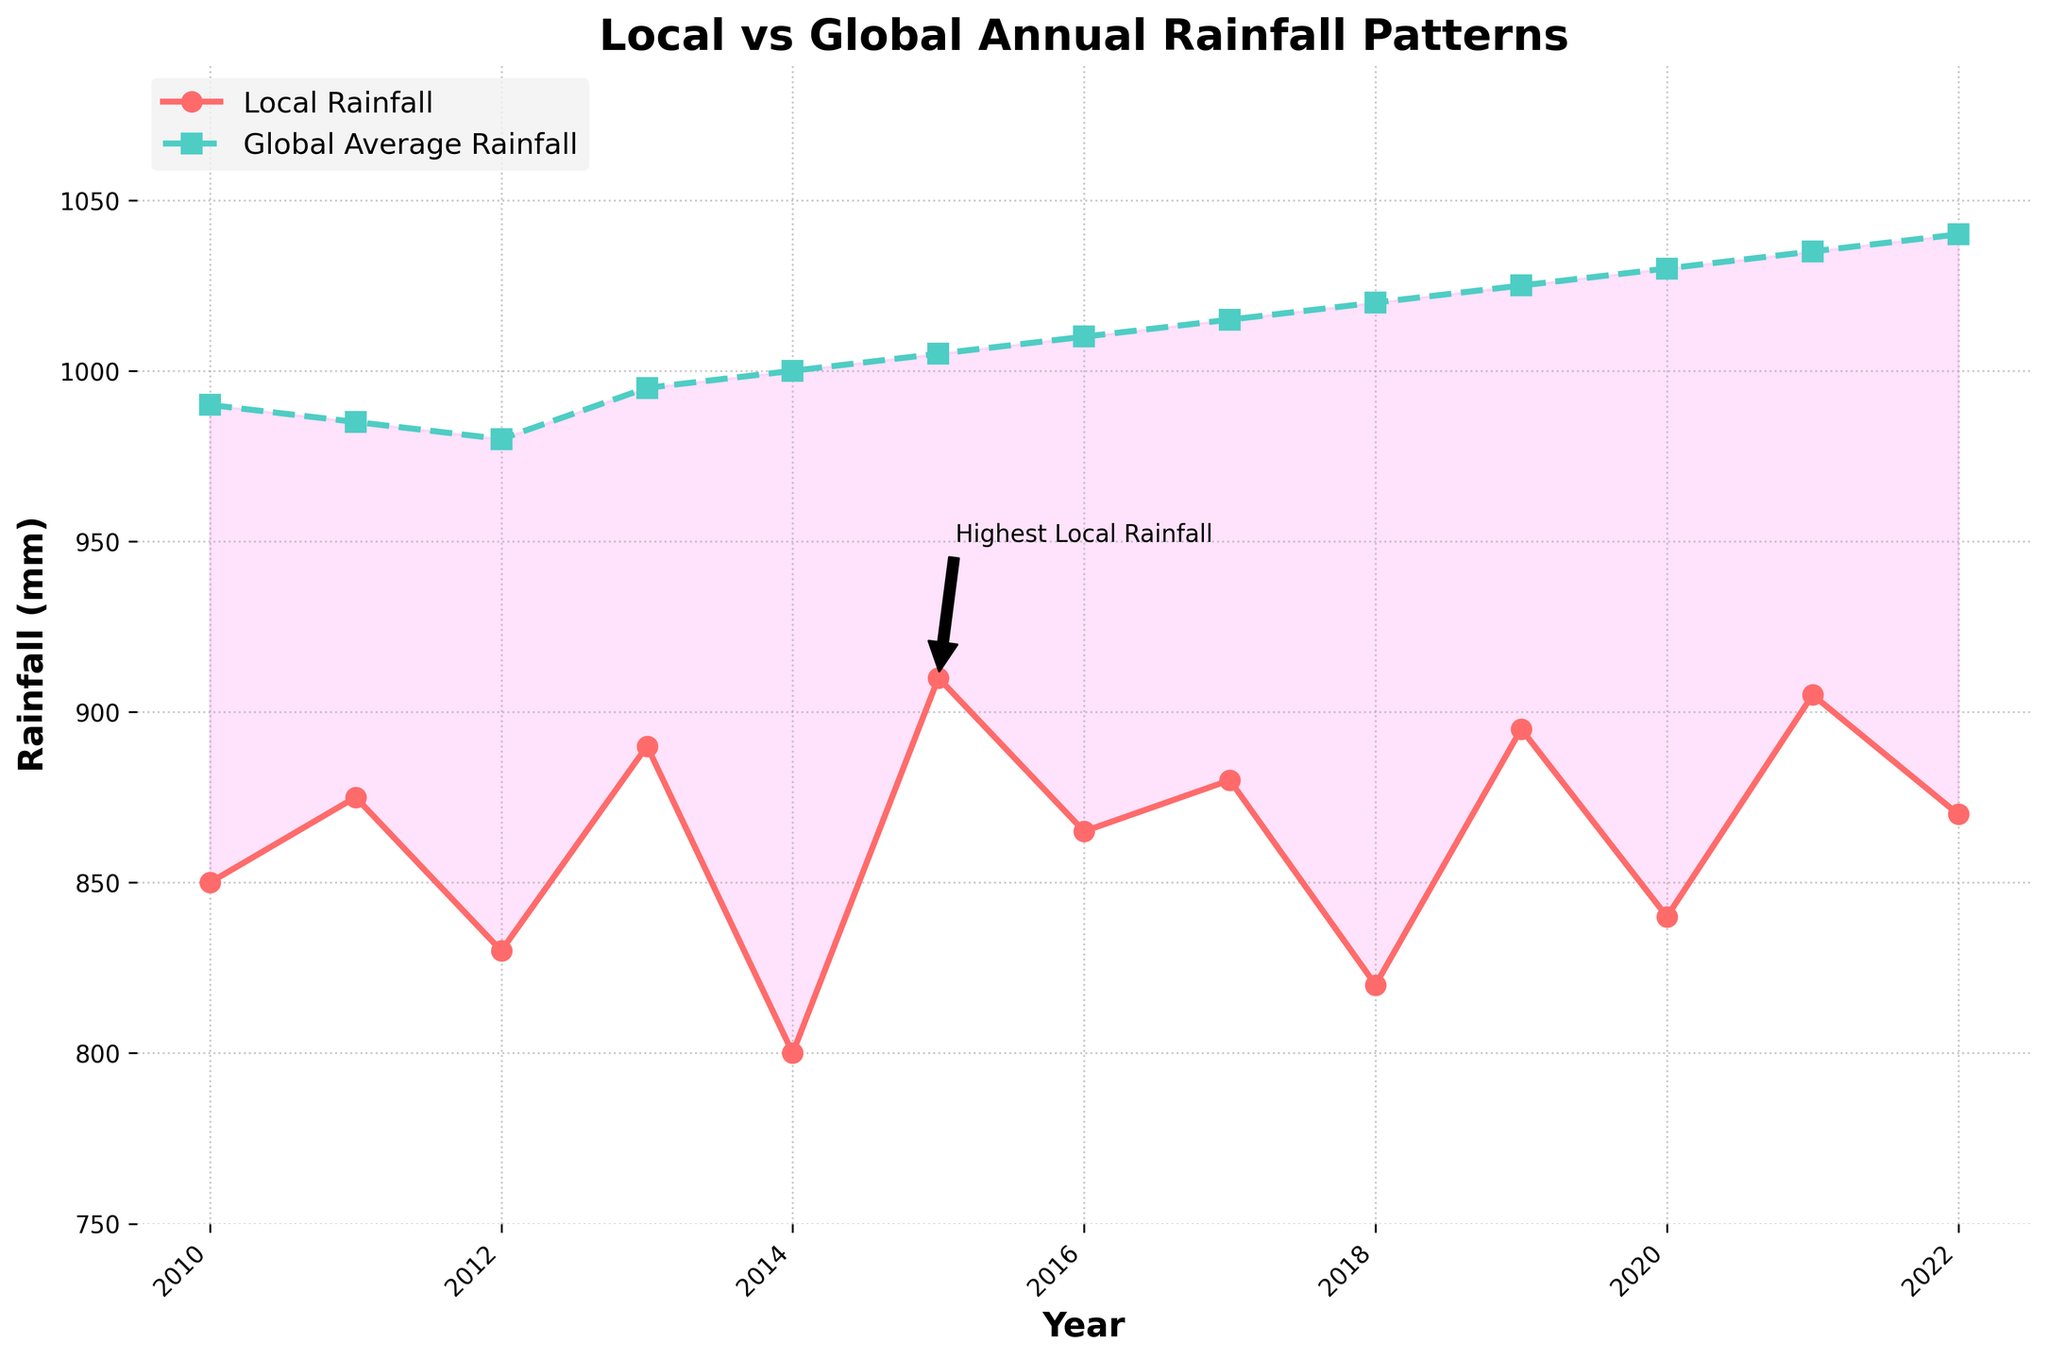What trend do you notice in the local rainfall pattern from 2010 to 2022? The local rainfall shows a fluctuating pattern with no consistent upwards or downwards trend. It peaked in 2015 and had lower values around 2014 and 2018, ending relatively high in 2022.
Answer: Fluctuating without consistent trend Which year had the highest local rainfall, and how does it compare to the global average rainfall of the same year? The highest local rainfall was in 2015, with 910 mm. The global average rainfall for the same year was 1005 mm. This means the local rainfall was 95 mm less than the global average rainfall that year.
Answer: 2015, 95 mm less What is the difference in local rainfall between the years 2014 and 2021? The local rainfall in 2014 was 800 mm, while in 2021, it was 905 mm. The difference between these two years is 905 mm - 800 mm = 105 mm.
Answer: 105 mm Which year had the lowest global average rainfall and what was the local rainfall that year? The lowest global average rainfall was in 2012 with 980 mm. The local rainfall that year was 830 mm.
Answer: 2012, 830 mm How many times did the local rainfall exceed the global average rainfall within the given period? Local rainfall exceeded global average rainfall in 0 of the given years. Every year, the global average was higher than the local rainfall.
Answer: 0 times By how much did the global average rainfall increase from 2010 to 2022? The global average rainfall in 2010 was 990 mm, and in 2022, it was 1040 mm. The increase over these years is 1040 mm - 990 mm = 50 mm.
Answer: 50 mm During which years is the area between the local and global rainfall shaded, and what does this shading indicate? The shading occurs where the local rainfall is less than the global average rainfall, which is the case for all years from 2010 to 2022. The shading indicates a rainfall deficit for the local area.
Answer: 2010-2022, rainfall deficit How did the local rainfall in the year 2020 compare to the global average rainfall in the same year? In 2020, the local rainfall was 840 mm, while the global average rainfall was 1030 mm. Therefore, the local rainfall was 190 mm less than the global average rainfall.
Answer: 190 mm less In which year was the discrepancy between local and global rainfall the greatest? In 2022, the local rainfall was 870 mm, and the global average rainfall was 1040 mm. The discrepancy is 1040 mm - 870 mm = 170 mm, which is the greatest among the years shown.
Answer: 2022, 170 mm What visual cues in the plot highlight the year with the highest local rainfall? The year 2015 is highlighted with an annotation marking it as the "Highest Local Rainfall" and an arrow pointing to the exact data point.
Answer: Highlighted annotation for 2015 